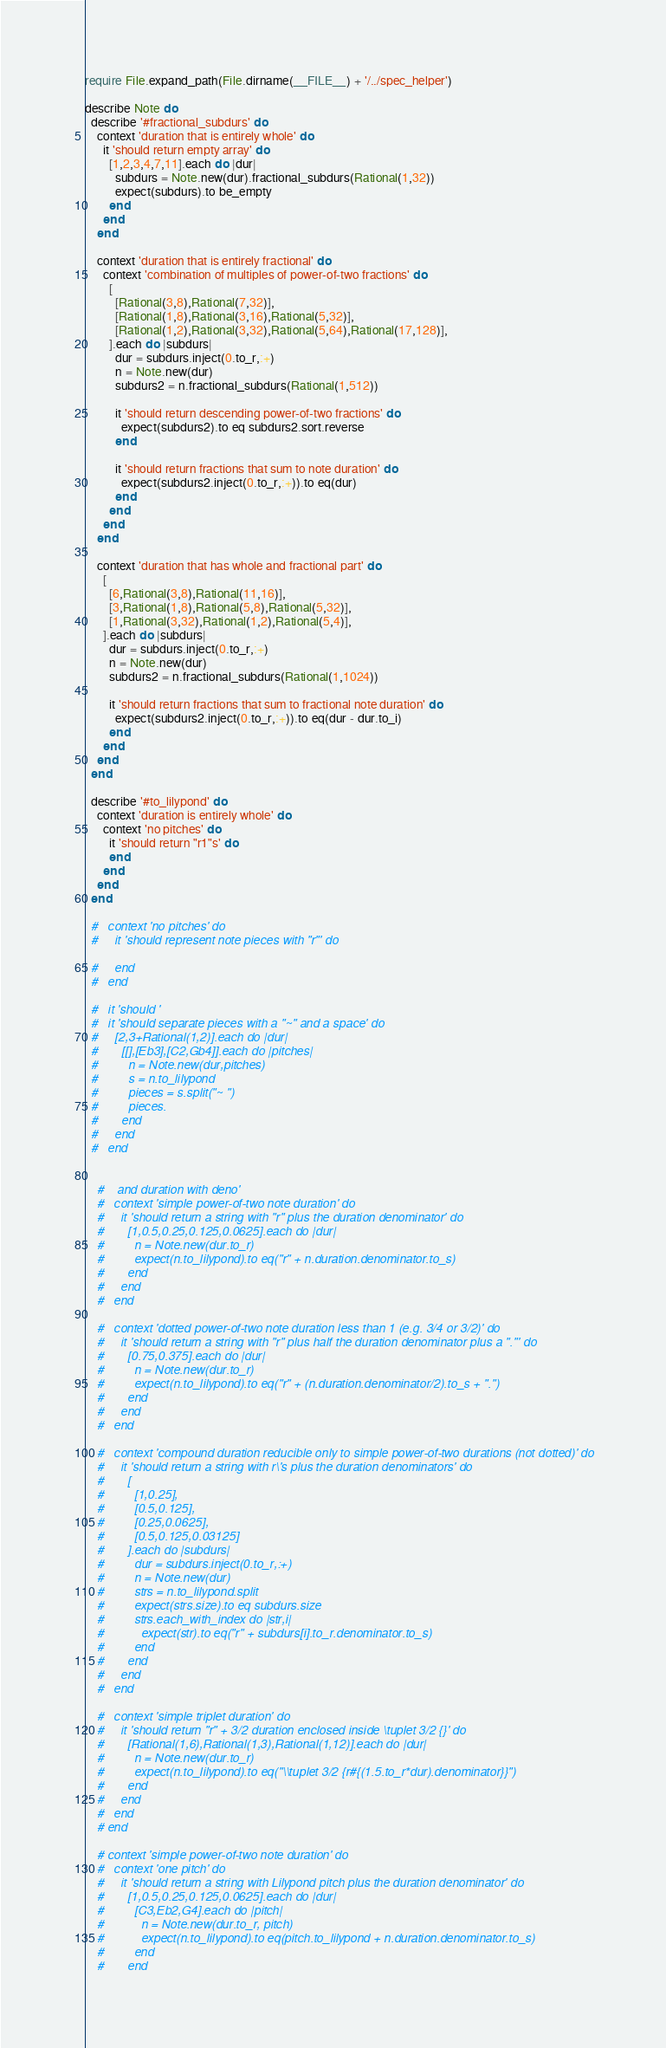Convert code to text. <code><loc_0><loc_0><loc_500><loc_500><_Ruby_>require File.expand_path(File.dirname(__FILE__) + '/../spec_helper')

describe Note do
  describe '#fractional_subdurs' do
    context 'duration that is entirely whole' do
      it 'should return empty array' do
        [1,2,3,4,7,11].each do |dur|
          subdurs = Note.new(dur).fractional_subdurs(Rational(1,32))
          expect(subdurs).to be_empty
        end
      end
    end

    context 'duration that is entirely fractional' do
      context 'combination of multiples of power-of-two fractions' do
        [
          [Rational(3,8),Rational(7,32)],
          [Rational(1,8),Rational(3,16),Rational(5,32)],
          [Rational(1,2),Rational(3,32),Rational(5,64),Rational(17,128)],
        ].each do |subdurs|
          dur = subdurs.inject(0.to_r,:+)
          n = Note.new(dur)
          subdurs2 = n.fractional_subdurs(Rational(1,512))

          it 'should return descending power-of-two fractions' do
            expect(subdurs2).to eq subdurs2.sort.reverse
          end

          it 'should return fractions that sum to note duration' do
            expect(subdurs2.inject(0.to_r,:+)).to eq(dur)
          end
        end
      end
    end

    context 'duration that has whole and fractional part' do
      [
        [6,Rational(3,8),Rational(11,16)],
        [3,Rational(1,8),Rational(5,8),Rational(5,32)],
        [1,Rational(3,32),Rational(1,2),Rational(5,4)],
      ].each do |subdurs|
        dur = subdurs.inject(0.to_r,:+)
        n = Note.new(dur)
        subdurs2 = n.fractional_subdurs(Rational(1,1024))

        it 'should return fractions that sum to fractional note duration' do
          expect(subdurs2.inject(0.to_r,:+)).to eq(dur - dur.to_i)
        end
      end
    end
  end

  describe '#to_lilypond' do
    context 'duration is entirely whole' do
      context 'no pitches' do
        it 'should return "r1"s' do
        end
      end
    end
  end

  #   context 'no pitches' do
  #     it 'should represent note pieces with "r"' do

  #     end
  #   end

  #   it 'should '
  #   it 'should separate pieces with a "~" and a space' do
  #     [2,3+Rational(1,2)].each do |dur|
  #       [[],[Eb3],[C2,Gb4]].each do |pitches|
  #         n = Note.new(dur,pitches)
  #         s = n.to_lilypond
  #         pieces = s.split("~ ")
  #         pieces.
  #       end
  #     end
  #   end


    #    and duration with deno'
    #   context 'simple power-of-two note duration' do
    #     it 'should return a string with "r" plus the duration denominator' do
    #       [1,0.5,0.25,0.125,0.0625].each do |dur|
    #         n = Note.new(dur.to_r)
    #         expect(n.to_lilypond).to eq("r" + n.duration.denominator.to_s)
    #       end
    #     end
    #   end

    #   context 'dotted power-of-two note duration less than 1 (e.g. 3/4 or 3/2)' do
    #     it 'should return a string with "r" plus half the duration denominator plus a "."' do
    #       [0.75,0.375].each do |dur|
    #         n = Note.new(dur.to_r)
    #         expect(n.to_lilypond).to eq("r" + (n.duration.denominator/2).to_s + ".")
    #       end
    #     end
    #   end

    #   context 'compound duration reducible only to simple power-of-two durations (not dotted)' do
    #     it 'should return a string with r\'s plus the duration denominators' do
    #       [
    #         [1,0.25],
    #         [0.5,0.125],
    #         [0.25,0.0625],
    #         [0.5,0.125,0.03125]
    #       ].each do |subdurs|
    #         dur = subdurs.inject(0.to_r,:+)
    #         n = Note.new(dur)
    #         strs = n.to_lilypond.split
    #         expect(strs.size).to eq subdurs.size
    #         strs.each_with_index do |str,i|
    #           expect(str).to eq("r" + subdurs[i].to_r.denominator.to_s)
    #         end
    #       end
    #     end
    #   end

    #   context 'simple triplet duration' do
    #     it 'should return "r" + 3/2 duration enclosed inside \tuplet 3/2 {}' do
    #       [Rational(1,6),Rational(1,3),Rational(1,12)].each do |dur|
    #         n = Note.new(dur.to_r)
    #         expect(n.to_lilypond).to eq("\\tuplet 3/2 {r#{(1.5.to_r*dur).denominator}}")
    #       end
    #     end
    #   end
    # end

    # context 'simple power-of-two note duration' do
    #   context 'one pitch' do
    #     it 'should return a string with Lilypond pitch plus the duration denominator' do
    #       [1,0.5,0.25,0.125,0.0625].each do |dur|
    #         [C3,Eb2,G4].each do |pitch|
    #           n = Note.new(dur.to_r, pitch)
    #           expect(n.to_lilypond).to eq(pitch.to_lilypond + n.duration.denominator.to_s)
    #         end
    #       end</code> 